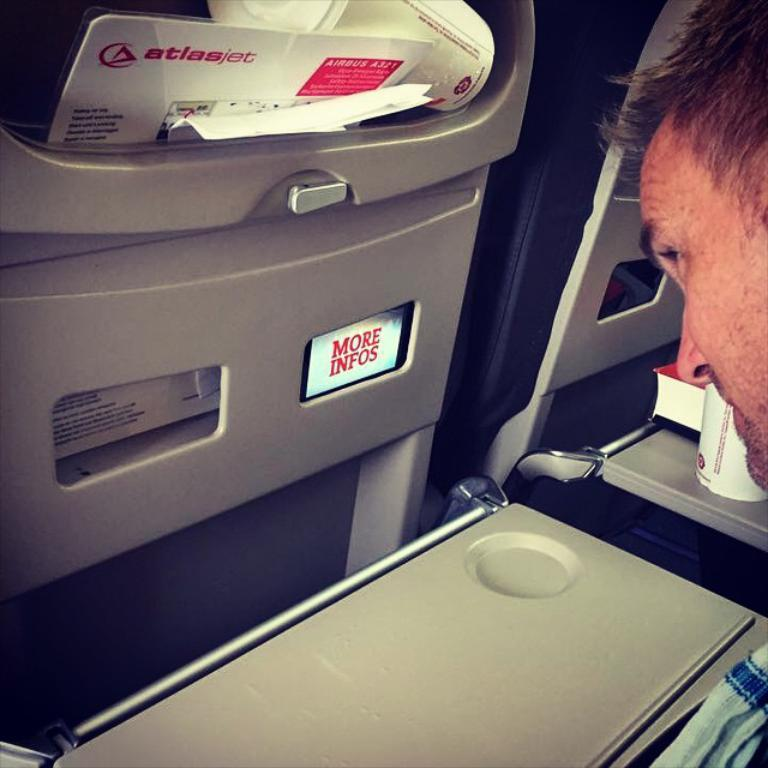Who or what is located on the right side of the image? There is a person on the right side of the image. What can be seen in the center of the image? There are devices visible in the center of the image. Can you describe any other objects present in the image? There are other objects present in the image, but their specific details are not mentioned in the provided facts. Where is the hen located in the image? There is no hen present in the image. What type of writing can be seen on the devices in the image? The provided facts do not mention any writing on the devices, so we cannot answer this question. 